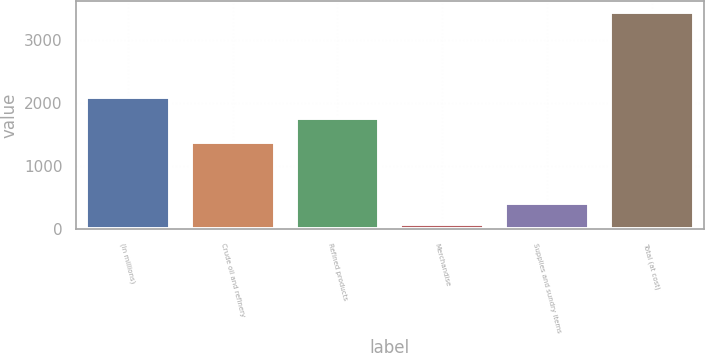<chart> <loc_0><loc_0><loc_500><loc_500><bar_chart><fcel>(In millions)<fcel>Crude oil and refinery<fcel>Refined products<fcel>Merchandise<fcel>Supplies and sundry items<fcel>Total (at cost)<nl><fcel>2098.5<fcel>1383<fcel>1761<fcel>74<fcel>411.5<fcel>3449<nl></chart> 